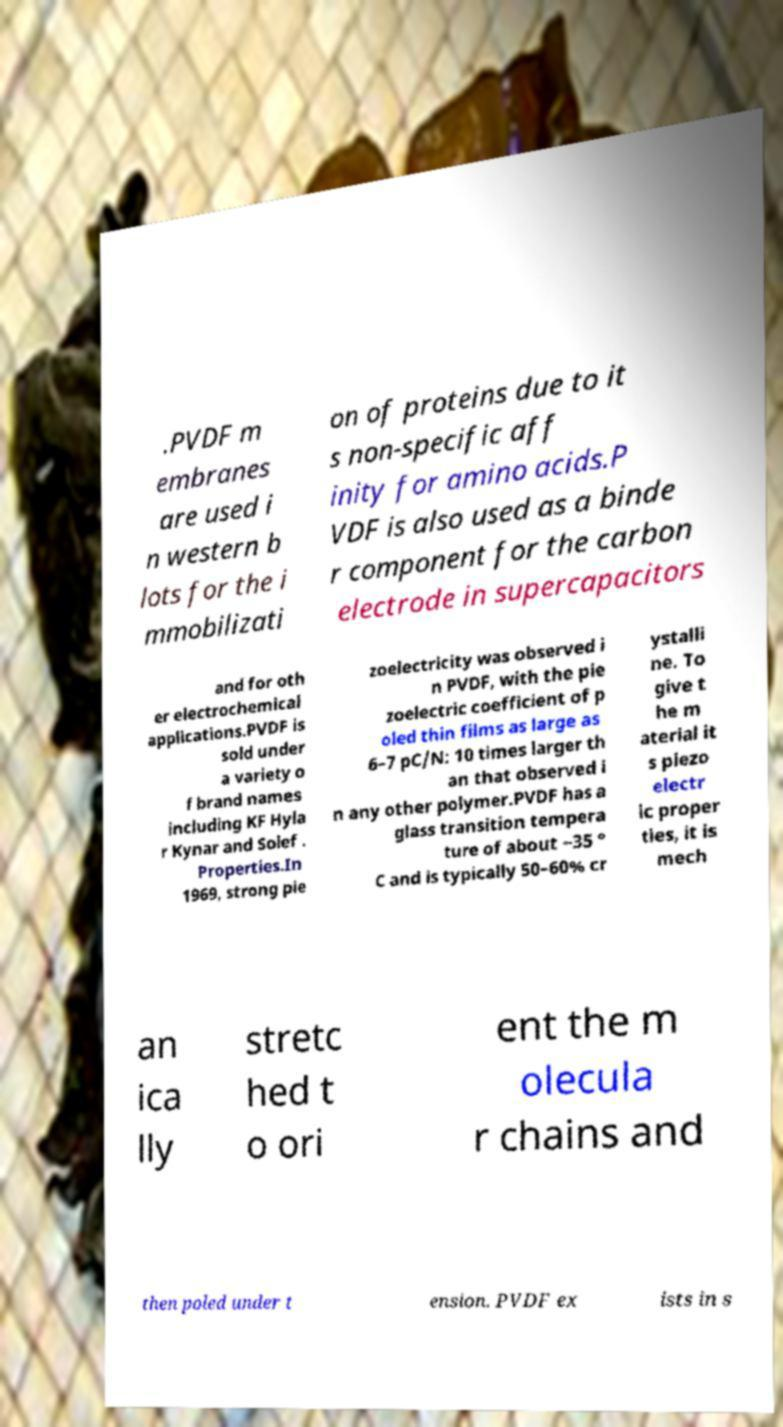I need the written content from this picture converted into text. Can you do that? .PVDF m embranes are used i n western b lots for the i mmobilizati on of proteins due to it s non-specific aff inity for amino acids.P VDF is also used as a binde r component for the carbon electrode in supercapacitors and for oth er electrochemical applications.PVDF is sold under a variety o f brand names including KF Hyla r Kynar and Solef . Properties.In 1969, strong pie zoelectricity was observed i n PVDF, with the pie zoelectric coefficient of p oled thin films as large as 6–7 pC/N: 10 times larger th an that observed i n any other polymer.PVDF has a glass transition tempera ture of about −35 ° C and is typically 50–60% cr ystalli ne. To give t he m aterial it s piezo electr ic proper ties, it is mech an ica lly stretc hed t o ori ent the m olecula r chains and then poled under t ension. PVDF ex ists in s 